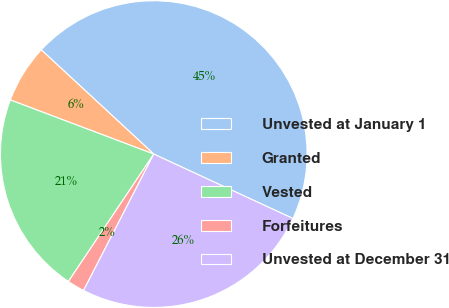<chart> <loc_0><loc_0><loc_500><loc_500><pie_chart><fcel>Unvested at January 1<fcel>Granted<fcel>Vested<fcel>Forfeitures<fcel>Unvested at December 31<nl><fcel>45.01%<fcel>6.15%<fcel>21.35%<fcel>1.83%<fcel>25.67%<nl></chart> 